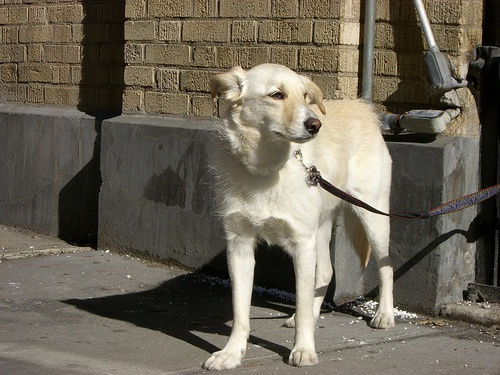Describe the objects in this image and their specific colors. I can see a dog in gray, beige, tan, and darkgray tones in this image. 